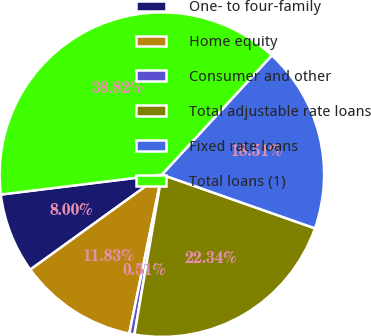<chart> <loc_0><loc_0><loc_500><loc_500><pie_chart><fcel>One- to four-family<fcel>Home equity<fcel>Consumer and other<fcel>Total adjustable rate loans<fcel>Fixed rate loans<fcel>Total loans (1)<nl><fcel>8.0%<fcel>11.83%<fcel>0.51%<fcel>22.34%<fcel>18.51%<fcel>38.82%<nl></chart> 